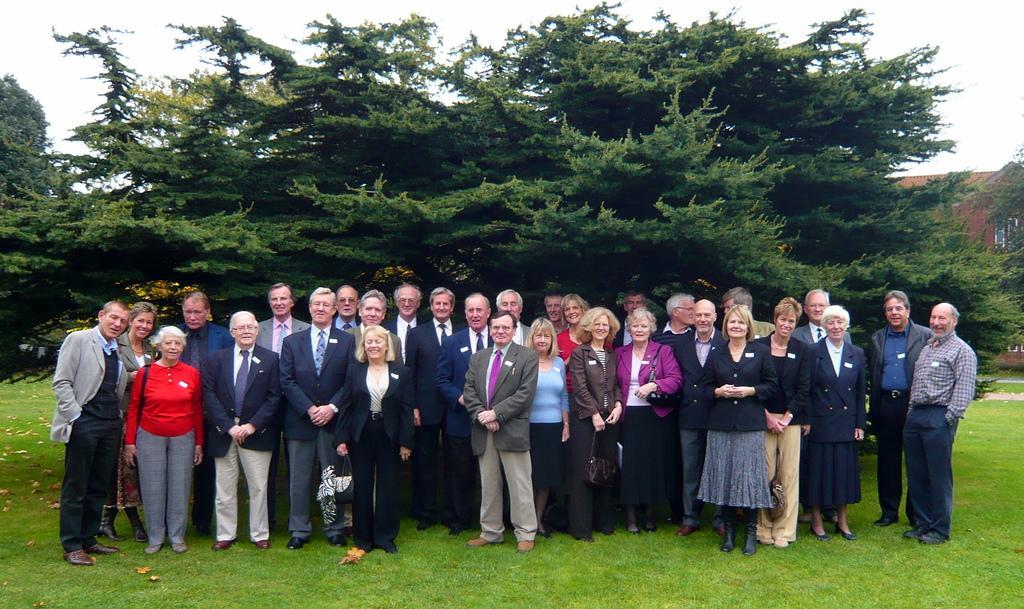Please provide a concise description of this image. In this picture, we see the group of people are standing. All of them are smiling and they are posing for the photo. At the bottom, we see the grass. On the left side, we see the dry leaves. On the right side, we see a building in brown color. There are trees in the background. At the top, we see the sky. 